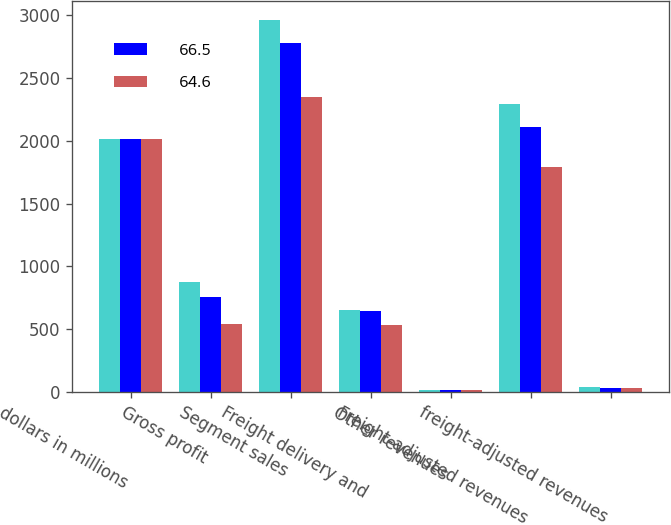Convert chart to OTSL. <chart><loc_0><loc_0><loc_500><loc_500><stacked_bar_chart><ecel><fcel>dollars in millions<fcel>Gross profit<fcel>Segment sales<fcel>Freight delivery and<fcel>Other revenues<fcel>Freight-adjusted revenues<fcel>freight-adjusted revenues<nl><fcel>nan<fcel>2016<fcel>873.1<fcel>2961.8<fcel>651.9<fcel>15.7<fcel>2294.2<fcel>38.1<nl><fcel>66.5<fcel>2015<fcel>755.7<fcel>2777.8<fcel>644.7<fcel>20.6<fcel>2112.5<fcel>35.8<nl><fcel>64.6<fcel>2014<fcel>544.1<fcel>2346.4<fcel>532.2<fcel>20.2<fcel>1794<fcel>30.3<nl></chart> 